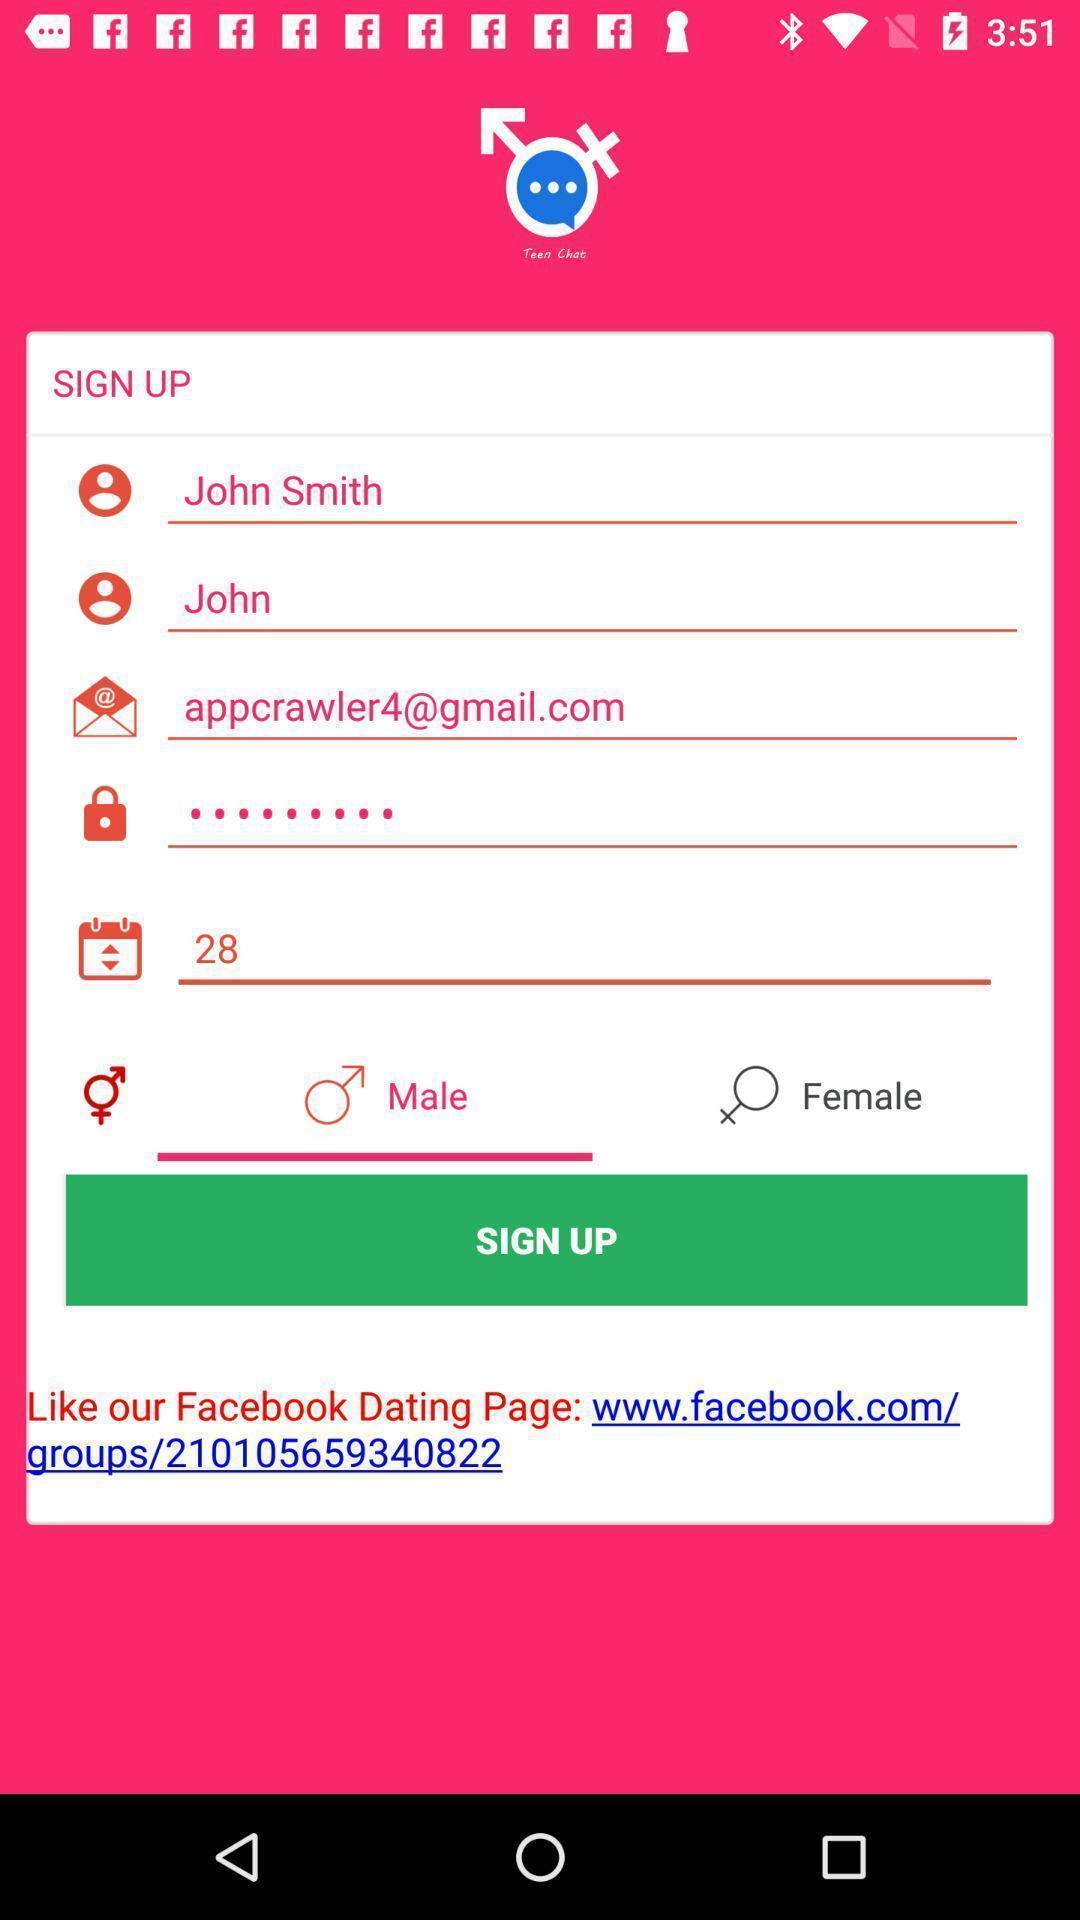What can you discern from this picture? Sign up screen. 